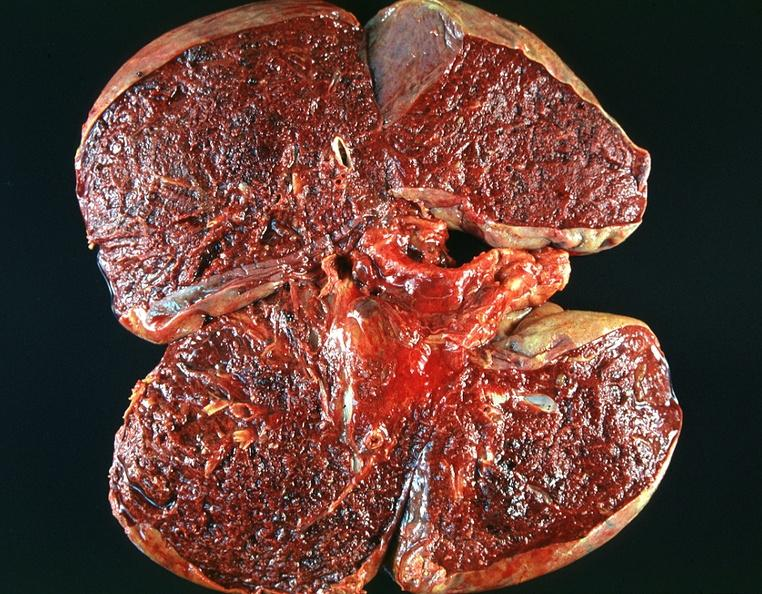does this image show lung, emphysema and pneumonia, alpha-1 antitrypsin deficiency?
Answer the question using a single word or phrase. Yes 